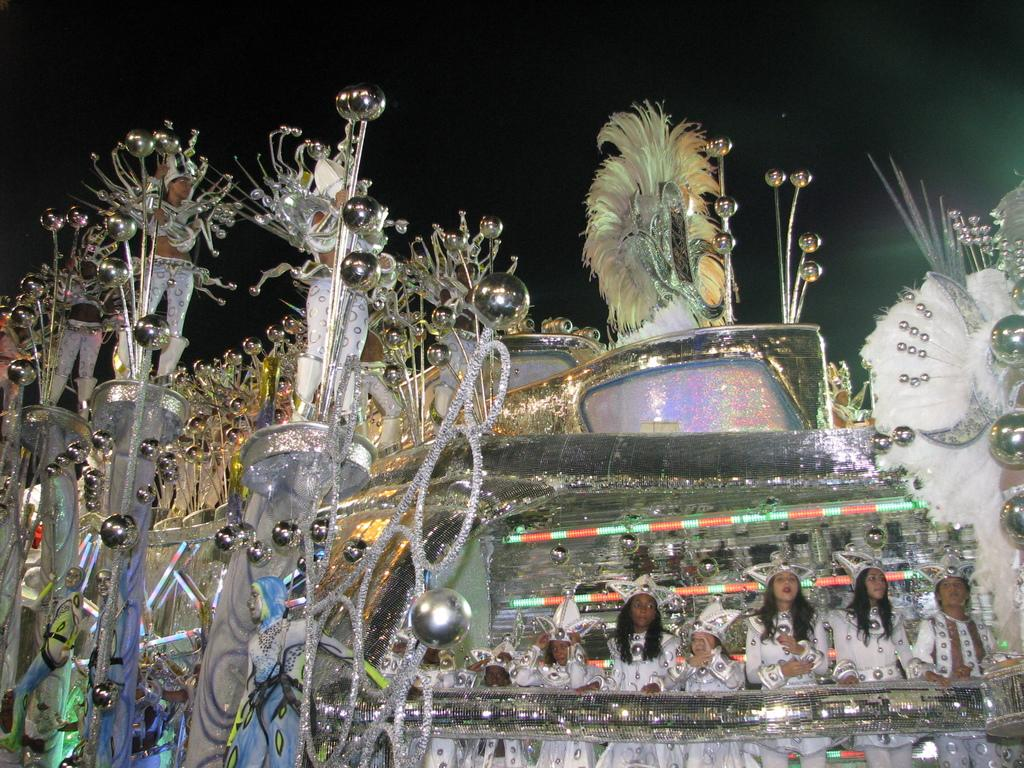Who is present in the image? There are people in the image. What are the people wearing? The people are wearing costumes. What are the people doing in the image? The people are standing and holding objects. What can be seen in the image that resembles a vehicle? There is a decorated object in the image that looks like a vehicle. How would you describe the background of the image? The background of the image is dark. What type of disease can be seen affecting the pig in the image? There is no pig present in the image, and therefore no disease can be observed. 